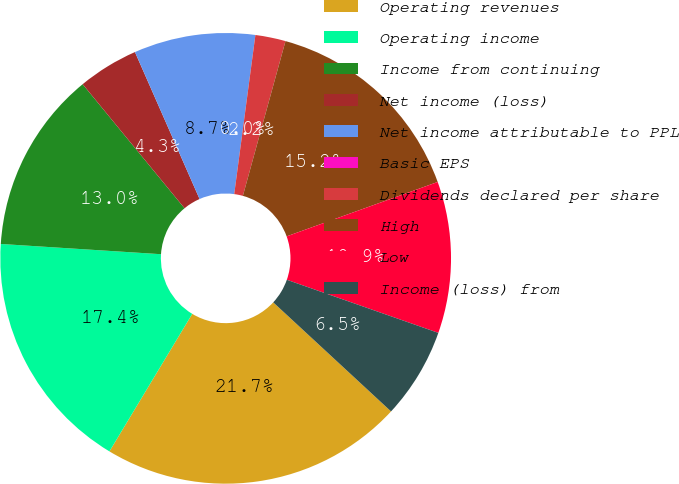Convert chart. <chart><loc_0><loc_0><loc_500><loc_500><pie_chart><fcel>Operating revenues<fcel>Operating income<fcel>Income from continuing<fcel>Net income (loss)<fcel>Net income attributable to PPL<fcel>Basic EPS<fcel>Dividends declared per share<fcel>High<fcel>Low<fcel>Income (loss) from<nl><fcel>21.74%<fcel>17.39%<fcel>13.04%<fcel>4.35%<fcel>8.7%<fcel>0.0%<fcel>2.17%<fcel>15.22%<fcel>10.87%<fcel>6.52%<nl></chart> 